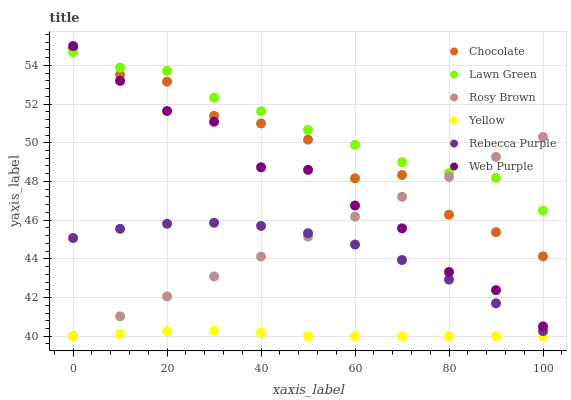Does Yellow have the minimum area under the curve?
Answer yes or no. Yes. Does Lawn Green have the maximum area under the curve?
Answer yes or no. Yes. Does Rosy Brown have the minimum area under the curve?
Answer yes or no. No. Does Rosy Brown have the maximum area under the curve?
Answer yes or no. No. Is Rosy Brown the smoothest?
Answer yes or no. Yes. Is Chocolate the roughest?
Answer yes or no. Yes. Is Yellow the smoothest?
Answer yes or no. No. Is Yellow the roughest?
Answer yes or no. No. Does Rosy Brown have the lowest value?
Answer yes or no. Yes. Does Chocolate have the lowest value?
Answer yes or no. No. Does Web Purple have the highest value?
Answer yes or no. Yes. Does Rosy Brown have the highest value?
Answer yes or no. No. Is Yellow less than Rebecca Purple?
Answer yes or no. Yes. Is Lawn Green greater than Rebecca Purple?
Answer yes or no. Yes. Does Web Purple intersect Rosy Brown?
Answer yes or no. Yes. Is Web Purple less than Rosy Brown?
Answer yes or no. No. Is Web Purple greater than Rosy Brown?
Answer yes or no. No. Does Yellow intersect Rebecca Purple?
Answer yes or no. No. 